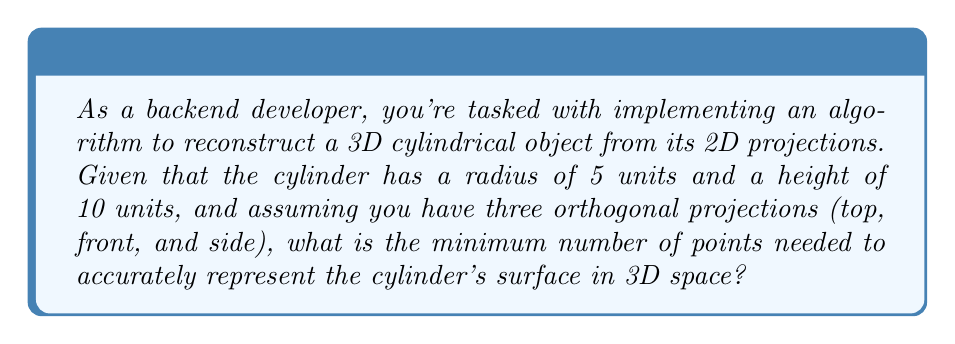Can you answer this question? Let's approach this step-by-step:

1) First, we need to understand the geometry of a cylinder:
   - It has two circular bases (top and bottom)
   - It has a curved lateral surface

2) To represent the cylinder accurately, we need to consider:
   - The circumference of the bases
   - The height of the cylinder

3) For the circular bases:
   - The formula for the circumference is $C = 2\pi r$
   - With $r = 5$, $C = 2\pi(5) = 10\pi$

4) To represent a circle digitally, we typically use a polygon approximation. The number of points needed depends on the desired accuracy. Let's assume we want at least 16 points per circle for a reasonable approximation.

5) For the height:
   - We need at least 2 points to represent the height (top and bottom)
   - However, to capture any potential variations along the height, let's use at least 4 points

6) Calculating the total number of points:
   - For the bases: 16 points × 2 bases = 32 points
   - For the height: 16 points (circumference) × 4 (height divisions) = 64 points

7) Total minimum number of points:
   32 (bases) + 64 (lateral surface) = 96 points

This approach ensures that we have enough points to represent both the circular bases and the curved lateral surface of the cylinder accurately.
Answer: 96 points 